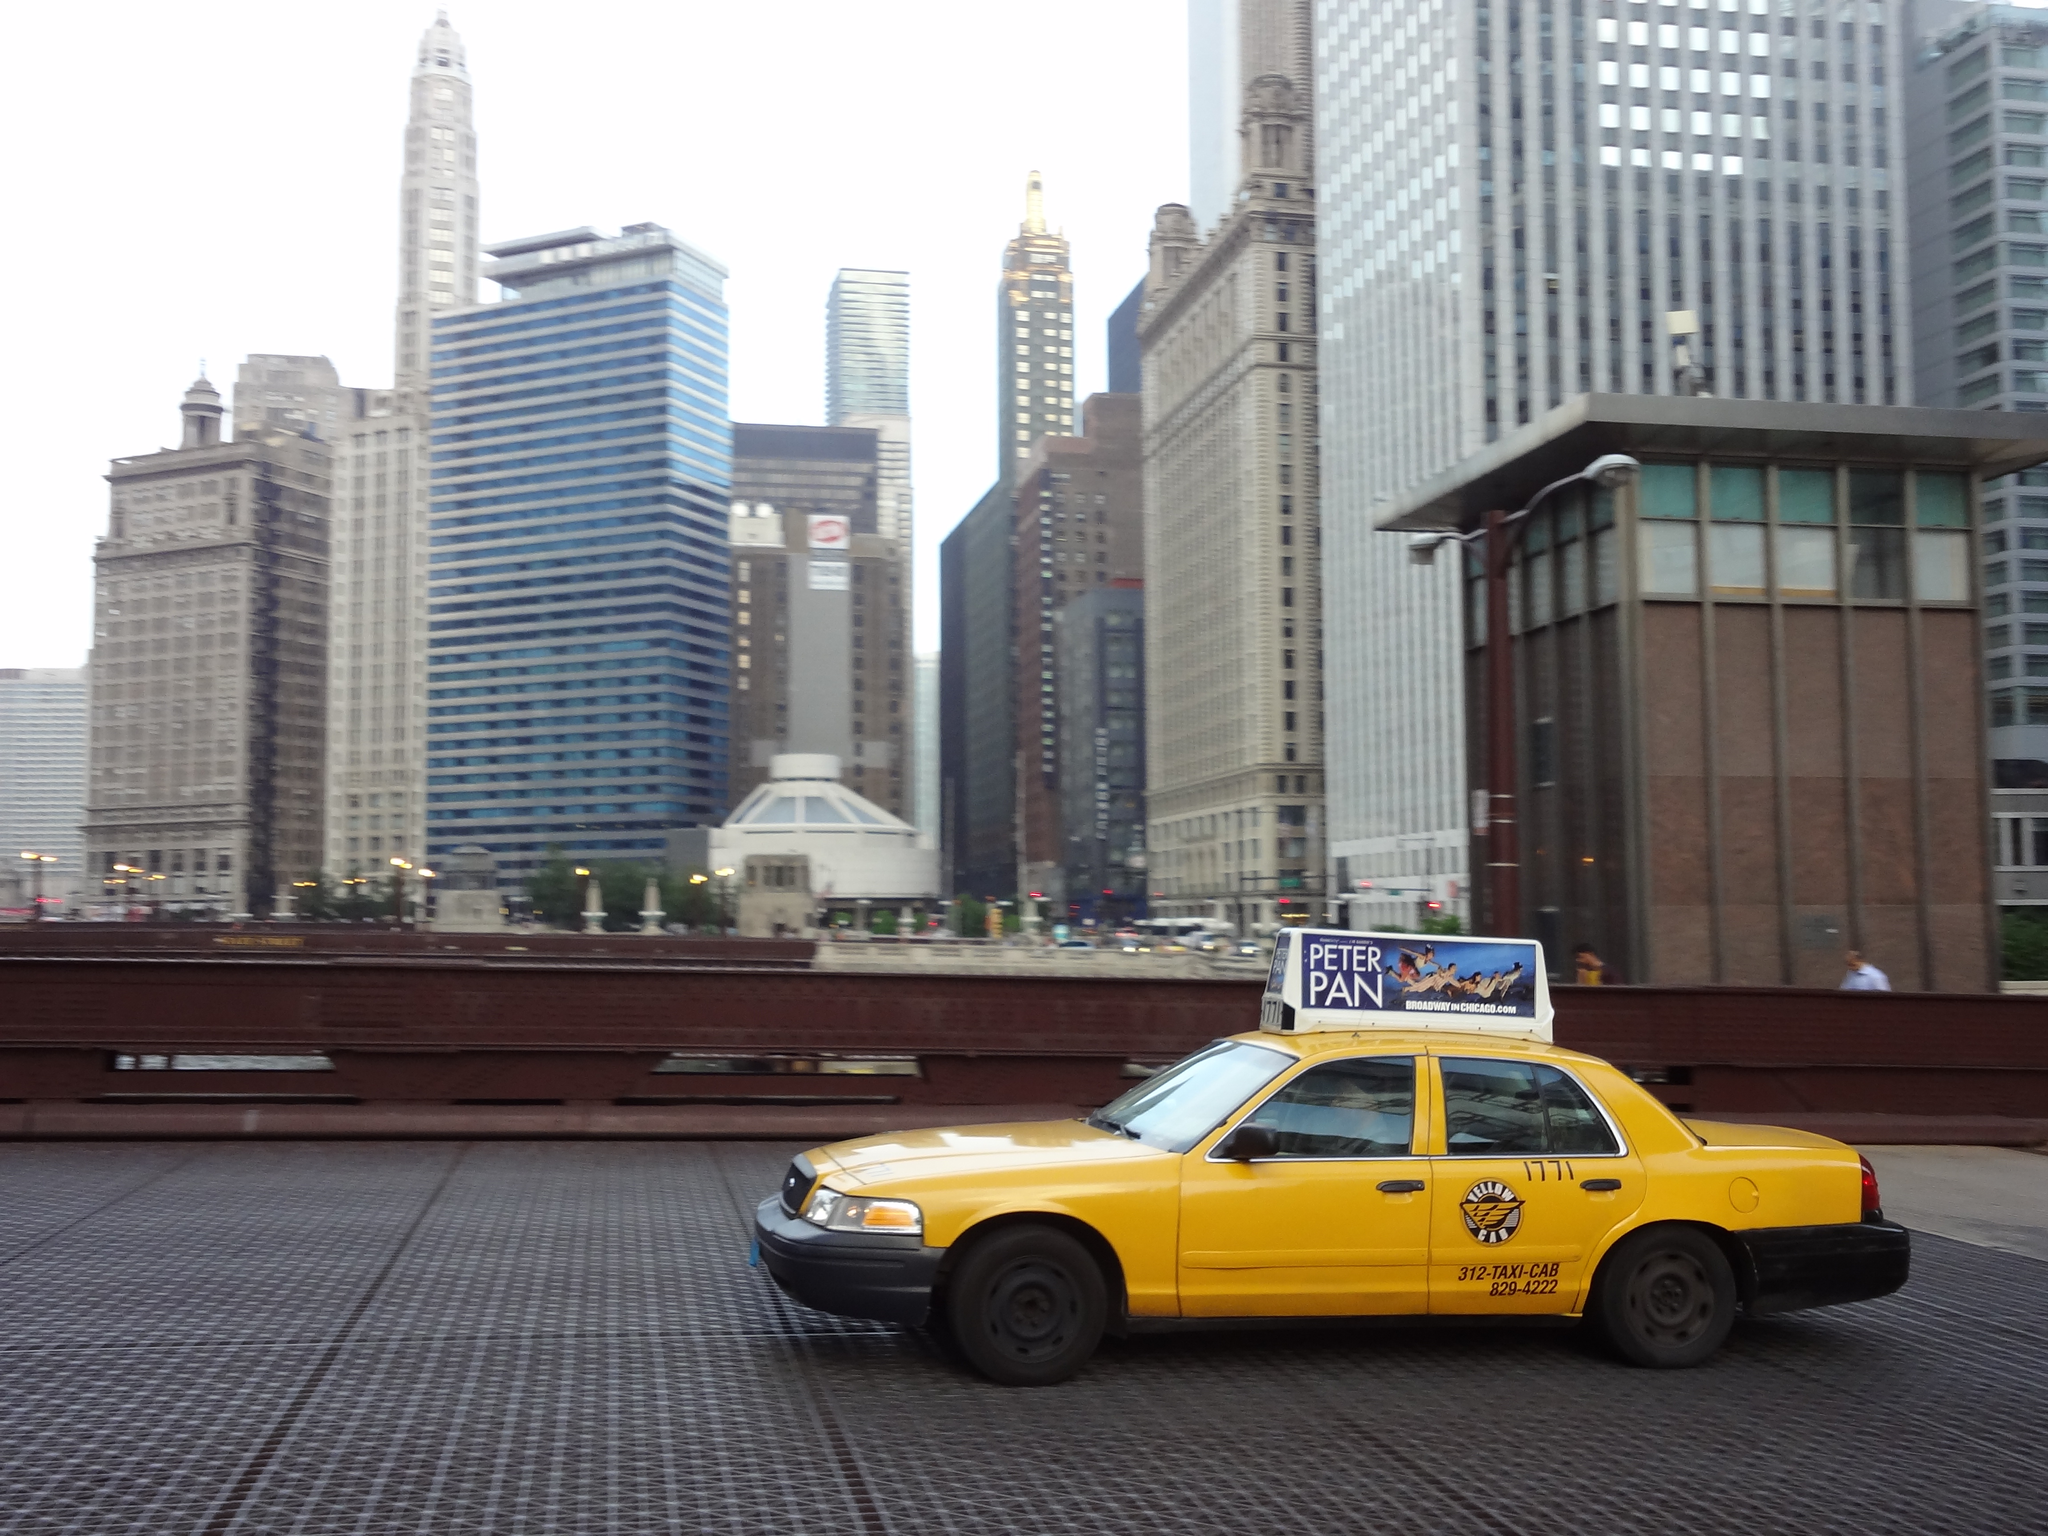<image>
Provide a brief description of the given image. A yellow city taxi cab driving along a city street. 